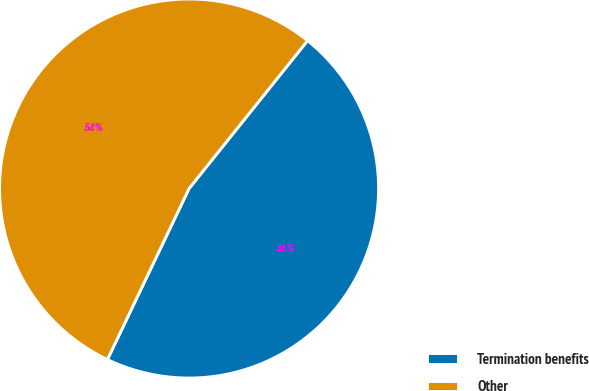Convert chart. <chart><loc_0><loc_0><loc_500><loc_500><pie_chart><fcel>Termination benefits<fcel>Other<nl><fcel>46.34%<fcel>53.66%<nl></chart> 